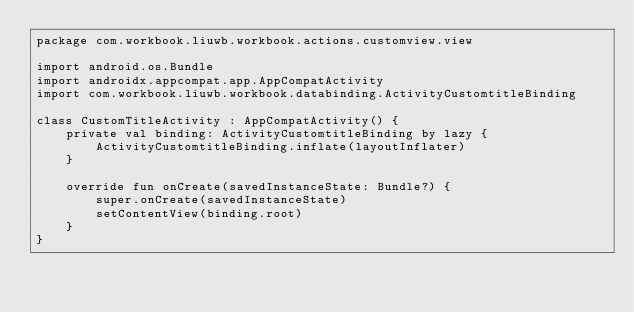<code> <loc_0><loc_0><loc_500><loc_500><_Kotlin_>package com.workbook.liuwb.workbook.actions.customview.view

import android.os.Bundle
import androidx.appcompat.app.AppCompatActivity
import com.workbook.liuwb.workbook.databinding.ActivityCustomtitleBinding

class CustomTitleActivity : AppCompatActivity() {
    private val binding: ActivityCustomtitleBinding by lazy {
        ActivityCustomtitleBinding.inflate(layoutInflater)
    }

    override fun onCreate(savedInstanceState: Bundle?) {
        super.onCreate(savedInstanceState)
        setContentView(binding.root)
    }
}</code> 